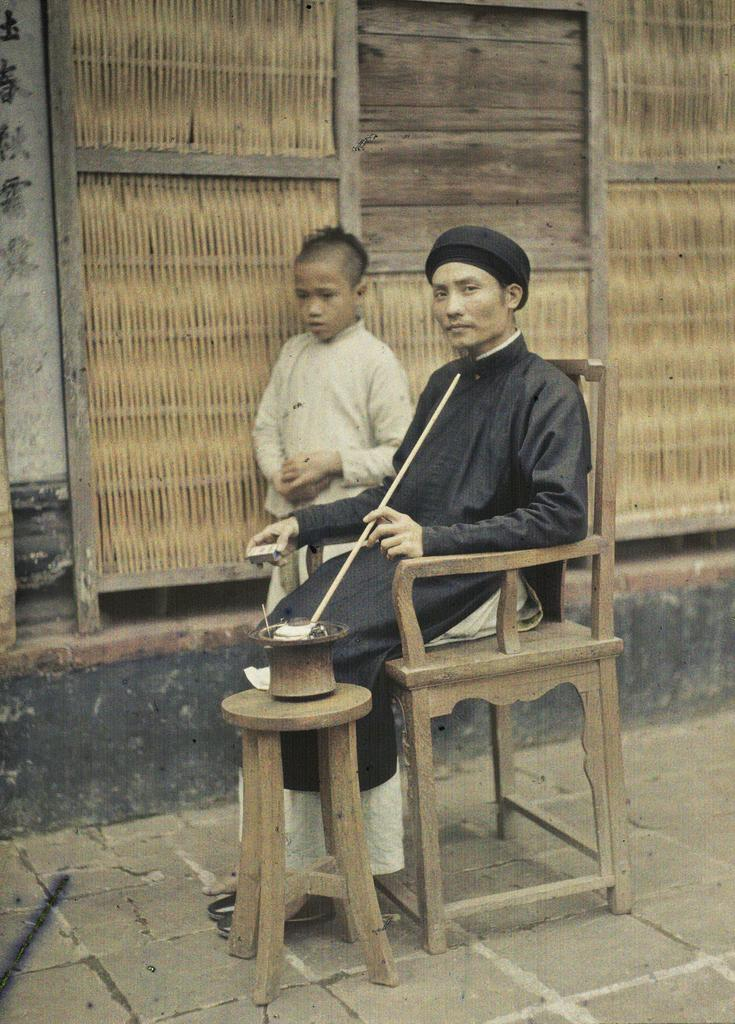What is the man doing in the image? The man is sitting on a wooden chair. Who is with the man in the image? There is a boy standing beside the man. What is placed beside the man? There is a table placed beside the man. What is in the bowl on the table? There is something in the bowl on the table, but the specific contents are not mentioned in the facts. What type of wine is being served in the image? There is no mention of wine in the image or the provided facts. 